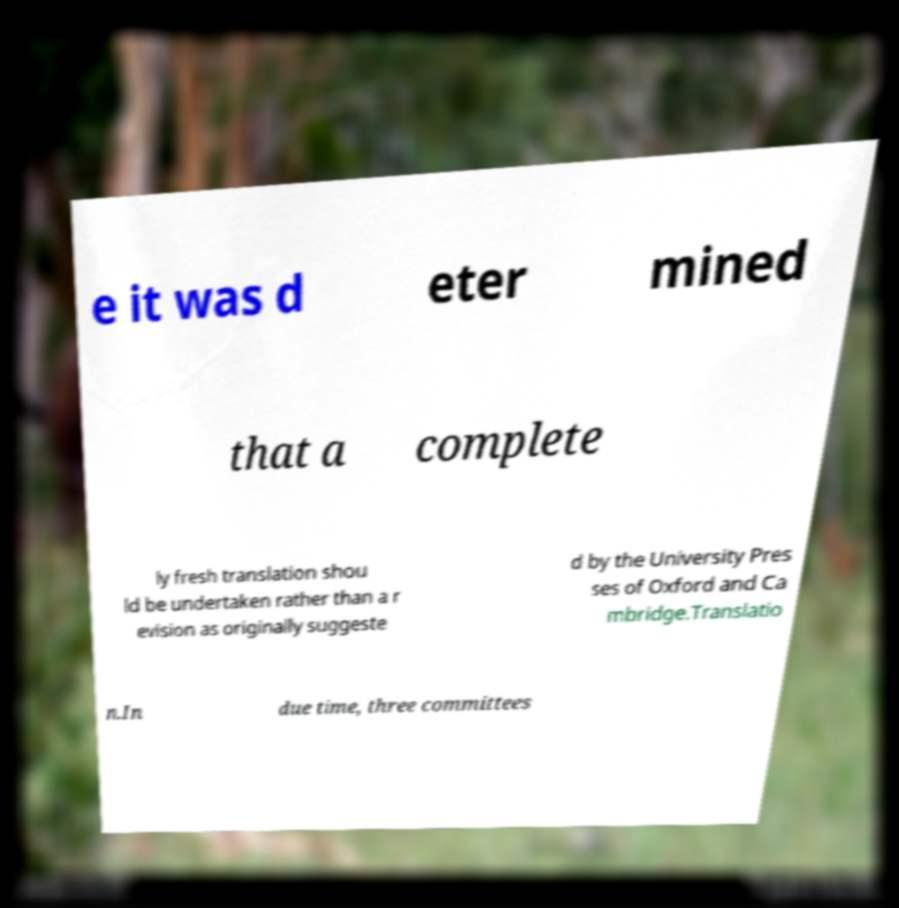Could you extract and type out the text from this image? e it was d eter mined that a complete ly fresh translation shou ld be undertaken rather than a r evision as originally suggeste d by the University Pres ses of Oxford and Ca mbridge.Translatio n.In due time, three committees 